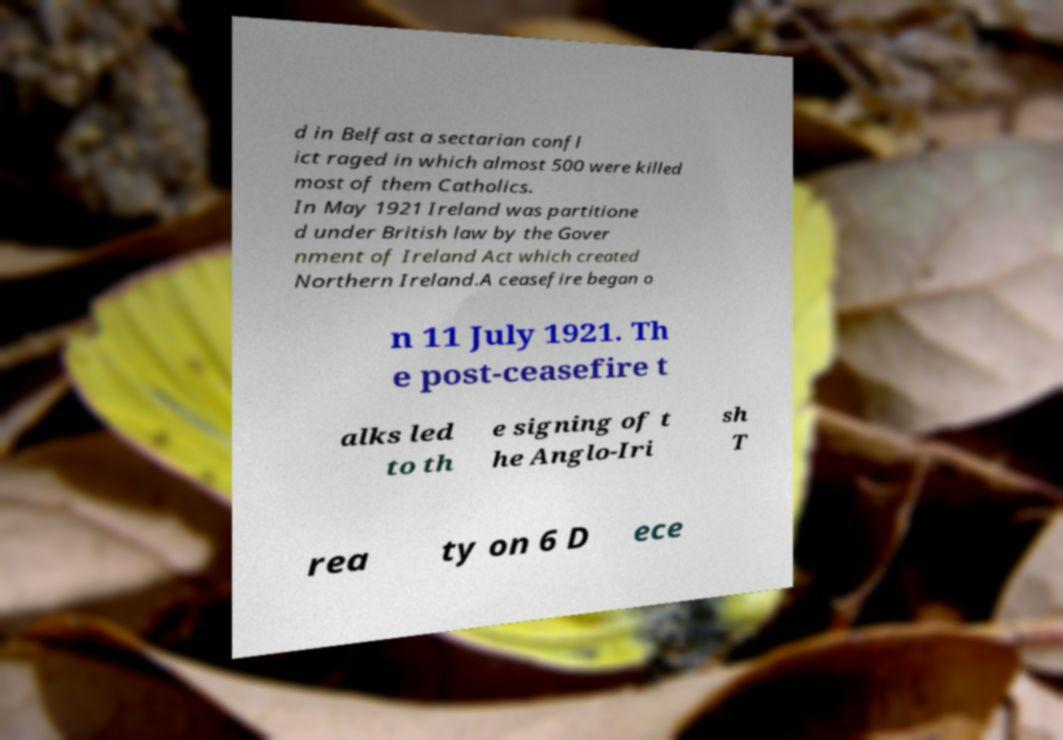I need the written content from this picture converted into text. Can you do that? d in Belfast a sectarian confl ict raged in which almost 500 were killed most of them Catholics. In May 1921 Ireland was partitione d under British law by the Gover nment of Ireland Act which created Northern Ireland.A ceasefire began o n 11 July 1921. Th e post-ceasefire t alks led to th e signing of t he Anglo-Iri sh T rea ty on 6 D ece 